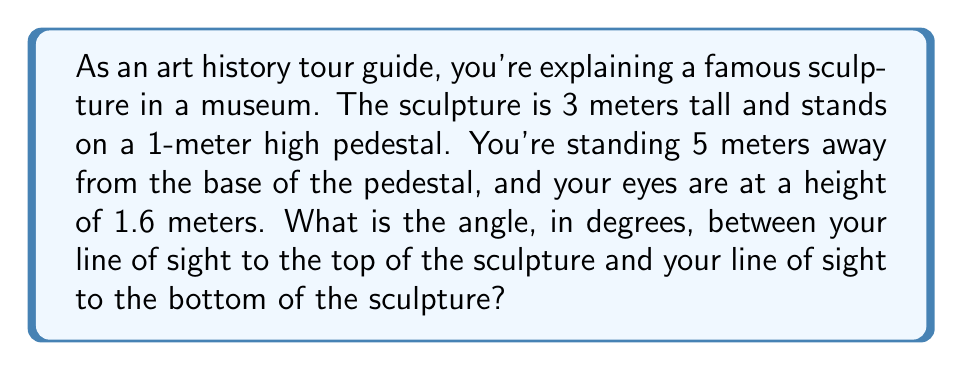Show me your answer to this math problem. Let's approach this step-by-step using trigonometry:

1) First, let's visualize the problem:

[asy]
unitsize(1cm);
draw((0,0)--(5,0)--(5,5.6)--(0,4)--(0,0));
draw((5,1.6)--(0,1),dashed);
draw((5,1.6)--(0,4),dashed);
label("Ground", (2.5,0), S);
label("Pedestal", (0,0.5), W);
label("Sculpture", (0,2.5), W);
label("Observer", (5,1.6), E);
label("$\theta$", (5.3,1.6), E);
label("5m", (2.5,0), N);
label("1m", (0,0.5), E);
label("3m", (0,2.5), E);
label("1.6m", (5,0.8), W);
[/asy]

2) We need to find the angle $\theta$ between the two lines of sight.

3) We can split this into two right triangles and use the arctangent function.

4) For the upper triangle:
   - Height difference = (1m + 3m) - 1.6m = 2.4m
   - Horizontal distance = 5m
   - Angle = $\arctan(\frac{2.4}{5})$

5) For the lower triangle:
   - Height difference = 1.6m - 1m = 0.6m
   - Horizontal distance = 5m
   - Angle = $\arctan(\frac{0.6}{5})$

6) The total angle $\theta$ is the difference between these two angles:

   $$\theta = \arctan(\frac{2.4}{5}) - \arctan(\frac{0.6}{5})$$

7) Let's calculate:
   $$\theta = \arctan(0.48) - \arctan(0.12)$$
   $$\theta \approx 25.64^\circ - 6.84^\circ = 18.80^\circ$$

8) Rounding to two decimal places, we get 18.80°.
Answer: The viewing angle is approximately 18.80°. 